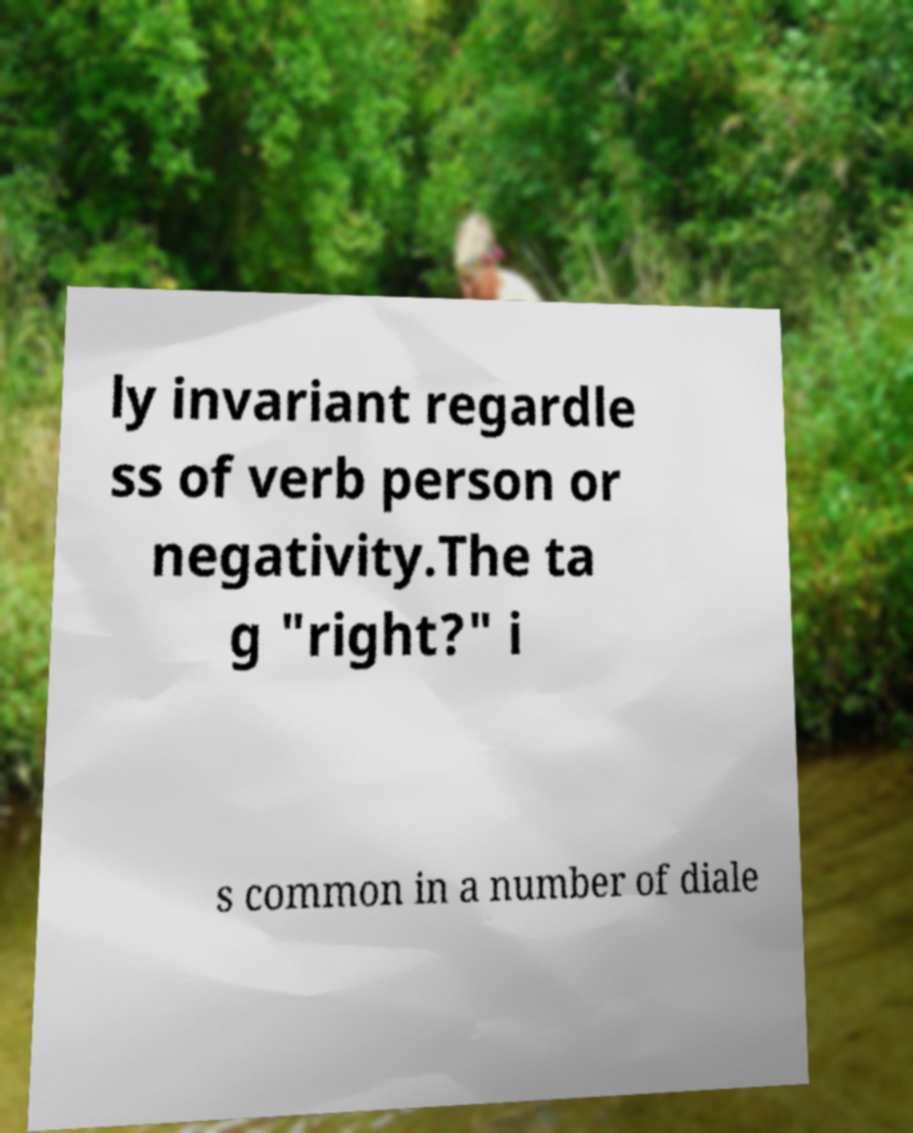Can you accurately transcribe the text from the provided image for me? ly invariant regardle ss of verb person or negativity.The ta g "right?" i s common in a number of diale 